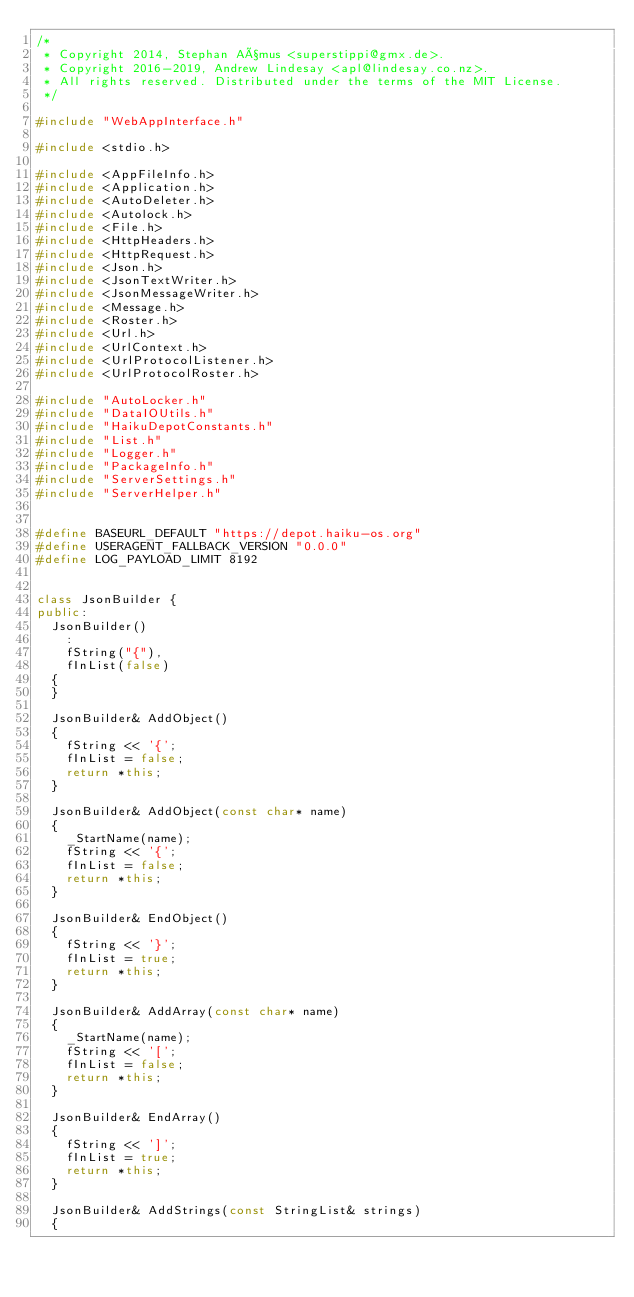<code> <loc_0><loc_0><loc_500><loc_500><_C++_>/*
 * Copyright 2014, Stephan Aßmus <superstippi@gmx.de>.
 * Copyright 2016-2019, Andrew Lindesay <apl@lindesay.co.nz>.
 * All rights reserved. Distributed under the terms of the MIT License.
 */

#include "WebAppInterface.h"

#include <stdio.h>

#include <AppFileInfo.h>
#include <Application.h>
#include <AutoDeleter.h>
#include <Autolock.h>
#include <File.h>
#include <HttpHeaders.h>
#include <HttpRequest.h>
#include <Json.h>
#include <JsonTextWriter.h>
#include <JsonMessageWriter.h>
#include <Message.h>
#include <Roster.h>
#include <Url.h>
#include <UrlContext.h>
#include <UrlProtocolListener.h>
#include <UrlProtocolRoster.h>

#include "AutoLocker.h"
#include "DataIOUtils.h"
#include "HaikuDepotConstants.h"
#include "List.h"
#include "Logger.h"
#include "PackageInfo.h"
#include "ServerSettings.h"
#include "ServerHelper.h"


#define BASEURL_DEFAULT "https://depot.haiku-os.org"
#define USERAGENT_FALLBACK_VERSION "0.0.0"
#define LOG_PAYLOAD_LIMIT 8192


class JsonBuilder {
public:
	JsonBuilder()
		:
		fString("{"),
		fInList(false)
	{
	}

	JsonBuilder& AddObject()
	{
		fString << '{';
		fInList = false;
		return *this;
	}

	JsonBuilder& AddObject(const char* name)
	{
		_StartName(name);
		fString << '{';
		fInList = false;
		return *this;
	}

	JsonBuilder& EndObject()
	{
		fString << '}';
		fInList = true;
		return *this;
	}

	JsonBuilder& AddArray(const char* name)
	{
		_StartName(name);
		fString << '[';
		fInList = false;
		return *this;
	}

	JsonBuilder& EndArray()
	{
		fString << ']';
		fInList = true;
		return *this;
	}

	JsonBuilder& AddStrings(const StringList& strings)
	{</code> 